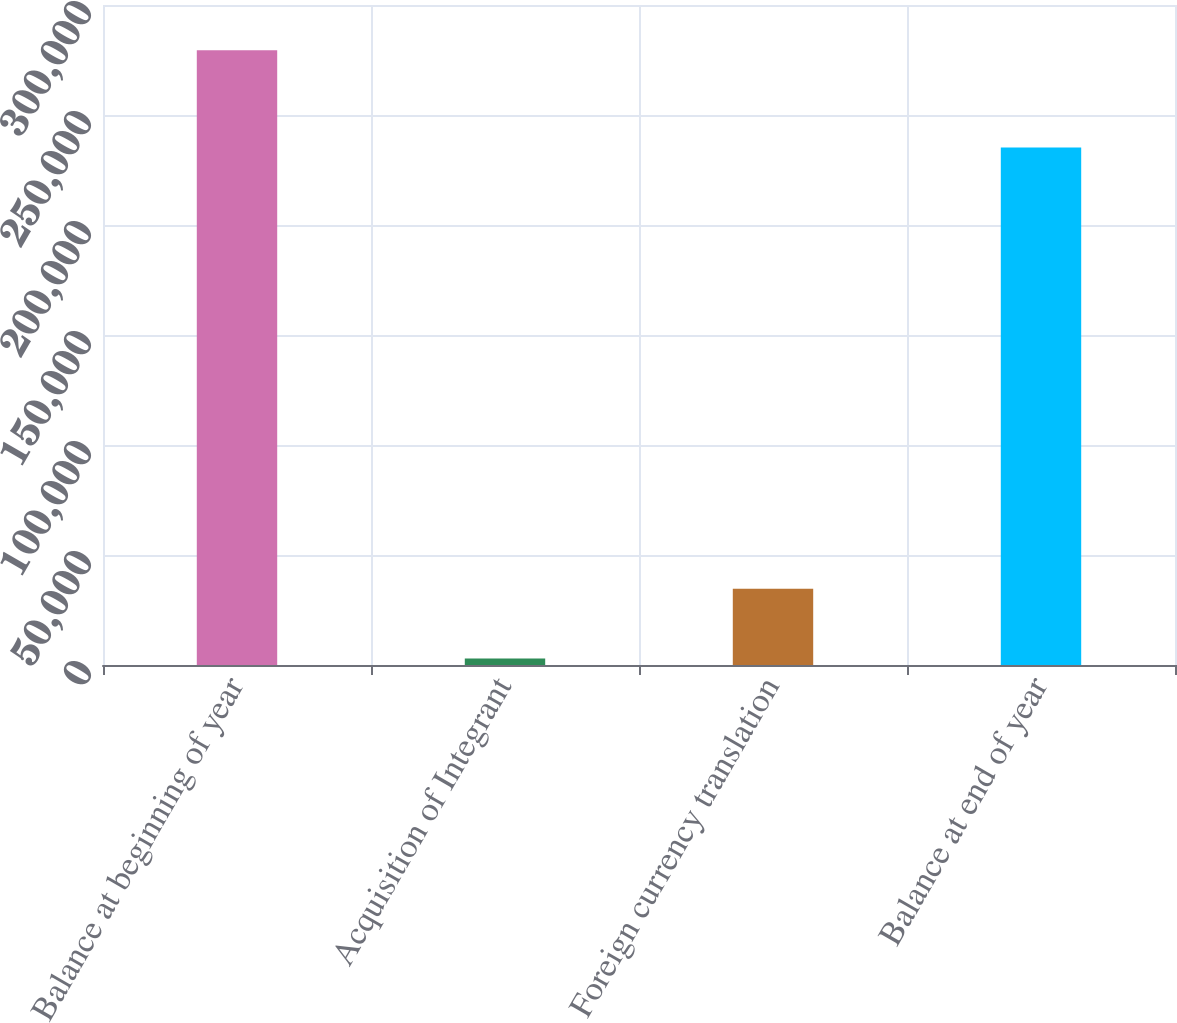<chart> <loc_0><loc_0><loc_500><loc_500><bar_chart><fcel>Balance at beginning of year<fcel>Acquisition of Integrant<fcel>Foreign currency translation<fcel>Balance at end of year<nl><fcel>279469<fcel>2988<fcel>34633<fcel>235175<nl></chart> 